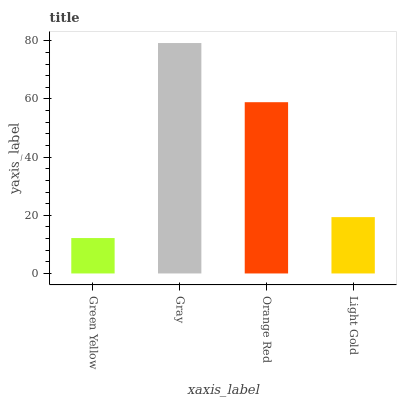Is Green Yellow the minimum?
Answer yes or no. Yes. Is Gray the maximum?
Answer yes or no. Yes. Is Orange Red the minimum?
Answer yes or no. No. Is Orange Red the maximum?
Answer yes or no. No. Is Gray greater than Orange Red?
Answer yes or no. Yes. Is Orange Red less than Gray?
Answer yes or no. Yes. Is Orange Red greater than Gray?
Answer yes or no. No. Is Gray less than Orange Red?
Answer yes or no. No. Is Orange Red the high median?
Answer yes or no. Yes. Is Light Gold the low median?
Answer yes or no. Yes. Is Gray the high median?
Answer yes or no. No. Is Green Yellow the low median?
Answer yes or no. No. 